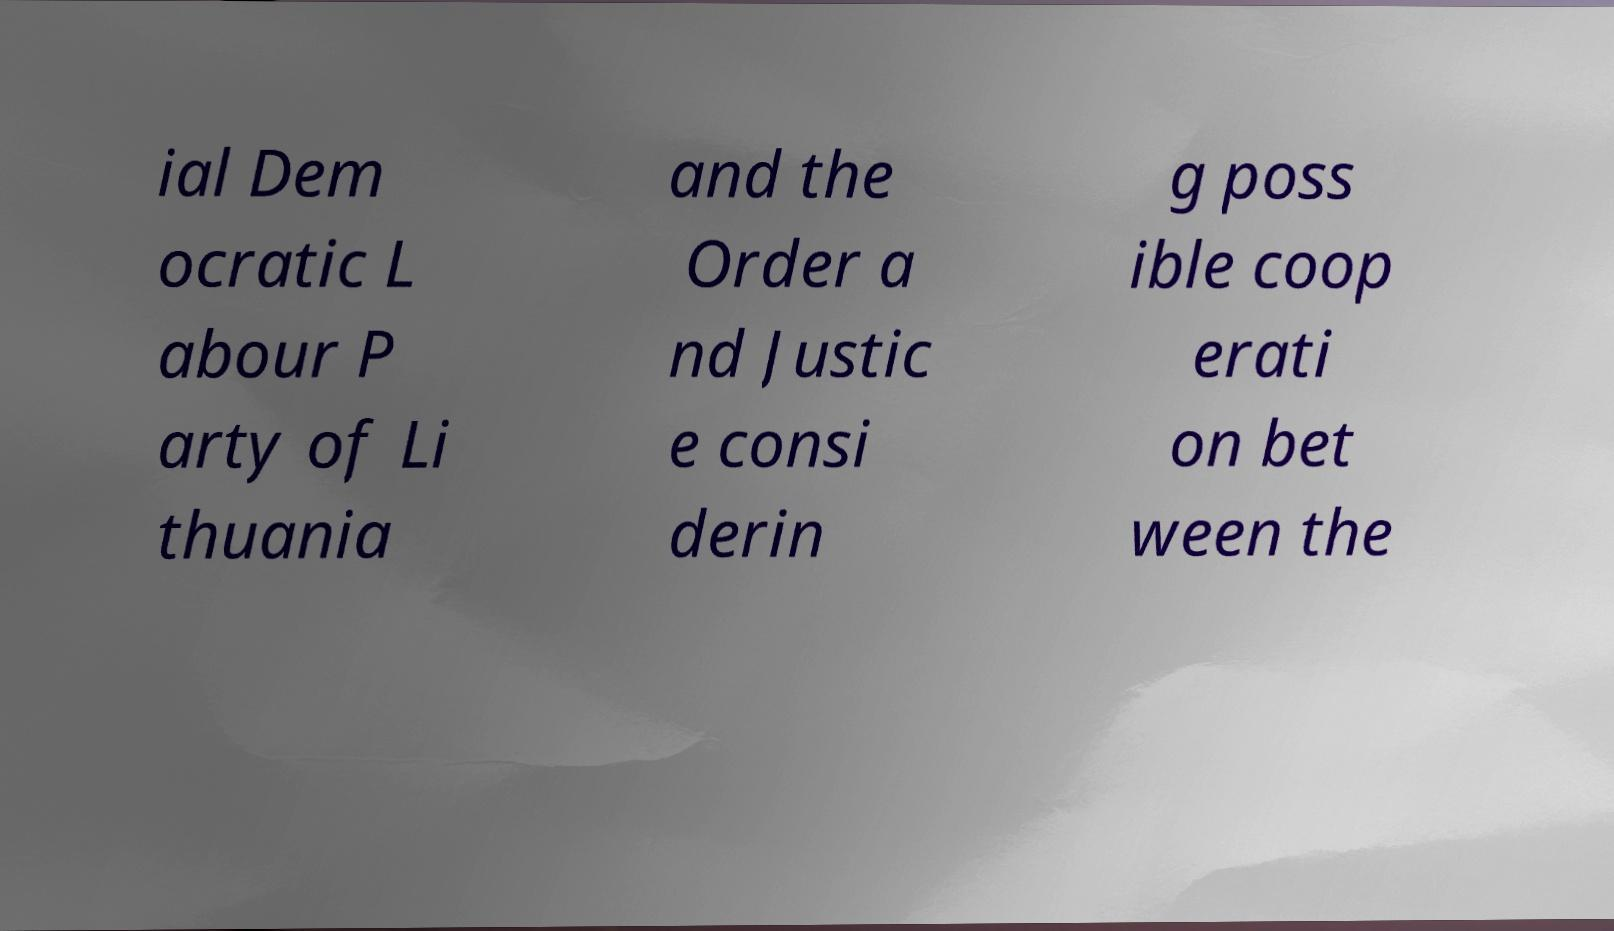Could you extract and type out the text from this image? ial Dem ocratic L abour P arty of Li thuania and the Order a nd Justic e consi derin g poss ible coop erati on bet ween the 